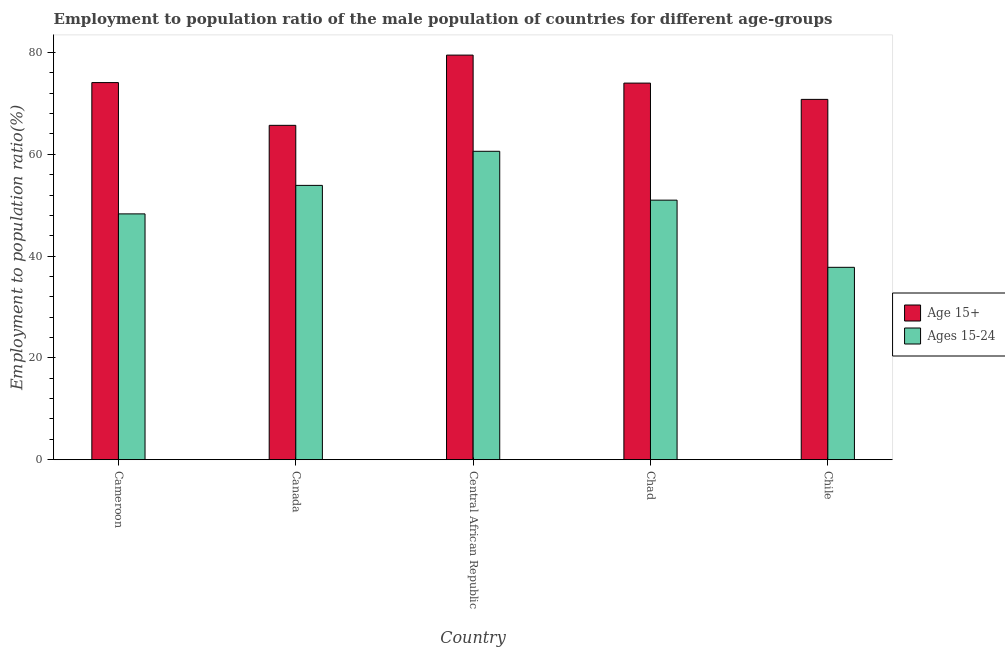How many groups of bars are there?
Ensure brevity in your answer.  5. Are the number of bars on each tick of the X-axis equal?
Keep it short and to the point. Yes. How many bars are there on the 2nd tick from the left?
Provide a short and direct response. 2. What is the label of the 1st group of bars from the left?
Your response must be concise. Cameroon. In how many cases, is the number of bars for a given country not equal to the number of legend labels?
Provide a short and direct response. 0. What is the employment to population ratio(age 15-24) in Cameroon?
Give a very brief answer. 48.3. Across all countries, what is the maximum employment to population ratio(age 15+)?
Give a very brief answer. 79.5. Across all countries, what is the minimum employment to population ratio(age 15-24)?
Provide a succinct answer. 37.8. In which country was the employment to population ratio(age 15+) maximum?
Provide a succinct answer. Central African Republic. In which country was the employment to population ratio(age 15+) minimum?
Give a very brief answer. Canada. What is the total employment to population ratio(age 15+) in the graph?
Ensure brevity in your answer.  364.1. What is the difference between the employment to population ratio(age 15+) in Central African Republic and that in Chile?
Your response must be concise. 8.7. What is the difference between the employment to population ratio(age 15+) in Chad and the employment to population ratio(age 15-24) in Central African Republic?
Keep it short and to the point. 13.4. What is the average employment to population ratio(age 15+) per country?
Keep it short and to the point. 72.82. In how many countries, is the employment to population ratio(age 15+) greater than 72 %?
Ensure brevity in your answer.  3. What is the ratio of the employment to population ratio(age 15+) in Cameroon to that in Central African Republic?
Provide a succinct answer. 0.93. Is the employment to population ratio(age 15+) in Cameroon less than that in Chad?
Provide a succinct answer. No. What is the difference between the highest and the second highest employment to population ratio(age 15+)?
Offer a very short reply. 5.4. What is the difference between the highest and the lowest employment to population ratio(age 15-24)?
Offer a very short reply. 22.8. Is the sum of the employment to population ratio(age 15-24) in Cameroon and Chile greater than the maximum employment to population ratio(age 15+) across all countries?
Your answer should be compact. Yes. What does the 2nd bar from the left in Chad represents?
Your response must be concise. Ages 15-24. What does the 2nd bar from the right in Cameroon represents?
Your answer should be very brief. Age 15+. Are all the bars in the graph horizontal?
Your answer should be very brief. No. How many countries are there in the graph?
Provide a succinct answer. 5. What is the difference between two consecutive major ticks on the Y-axis?
Keep it short and to the point. 20. How are the legend labels stacked?
Your response must be concise. Vertical. What is the title of the graph?
Ensure brevity in your answer.  Employment to population ratio of the male population of countries for different age-groups. Does "Diarrhea" appear as one of the legend labels in the graph?
Provide a short and direct response. No. What is the label or title of the Y-axis?
Provide a short and direct response. Employment to population ratio(%). What is the Employment to population ratio(%) in Age 15+ in Cameroon?
Offer a terse response. 74.1. What is the Employment to population ratio(%) of Ages 15-24 in Cameroon?
Your answer should be very brief. 48.3. What is the Employment to population ratio(%) of Age 15+ in Canada?
Your answer should be very brief. 65.7. What is the Employment to population ratio(%) in Ages 15-24 in Canada?
Give a very brief answer. 53.9. What is the Employment to population ratio(%) in Age 15+ in Central African Republic?
Give a very brief answer. 79.5. What is the Employment to population ratio(%) of Ages 15-24 in Central African Republic?
Offer a very short reply. 60.6. What is the Employment to population ratio(%) of Age 15+ in Chile?
Your answer should be compact. 70.8. What is the Employment to population ratio(%) in Ages 15-24 in Chile?
Your answer should be compact. 37.8. Across all countries, what is the maximum Employment to population ratio(%) of Age 15+?
Offer a terse response. 79.5. Across all countries, what is the maximum Employment to population ratio(%) in Ages 15-24?
Offer a terse response. 60.6. Across all countries, what is the minimum Employment to population ratio(%) of Age 15+?
Make the answer very short. 65.7. Across all countries, what is the minimum Employment to population ratio(%) in Ages 15-24?
Keep it short and to the point. 37.8. What is the total Employment to population ratio(%) in Age 15+ in the graph?
Keep it short and to the point. 364.1. What is the total Employment to population ratio(%) of Ages 15-24 in the graph?
Ensure brevity in your answer.  251.6. What is the difference between the Employment to population ratio(%) in Age 15+ in Cameroon and that in Canada?
Offer a terse response. 8.4. What is the difference between the Employment to population ratio(%) of Ages 15-24 in Cameroon and that in Central African Republic?
Offer a terse response. -12.3. What is the difference between the Employment to population ratio(%) of Age 15+ in Cameroon and that in Chad?
Offer a terse response. 0.1. What is the difference between the Employment to population ratio(%) in Ages 15-24 in Cameroon and that in Chile?
Your response must be concise. 10.5. What is the difference between the Employment to population ratio(%) in Age 15+ in Canada and that in Central African Republic?
Keep it short and to the point. -13.8. What is the difference between the Employment to population ratio(%) of Ages 15-24 in Canada and that in Central African Republic?
Your response must be concise. -6.7. What is the difference between the Employment to population ratio(%) in Age 15+ in Canada and that in Chad?
Give a very brief answer. -8.3. What is the difference between the Employment to population ratio(%) in Ages 15-24 in Canada and that in Chad?
Give a very brief answer. 2.9. What is the difference between the Employment to population ratio(%) of Age 15+ in Canada and that in Chile?
Your answer should be very brief. -5.1. What is the difference between the Employment to population ratio(%) of Ages 15-24 in Canada and that in Chile?
Your response must be concise. 16.1. What is the difference between the Employment to population ratio(%) in Age 15+ in Central African Republic and that in Chad?
Keep it short and to the point. 5.5. What is the difference between the Employment to population ratio(%) in Age 15+ in Central African Republic and that in Chile?
Provide a short and direct response. 8.7. What is the difference between the Employment to population ratio(%) in Ages 15-24 in Central African Republic and that in Chile?
Offer a terse response. 22.8. What is the difference between the Employment to population ratio(%) of Age 15+ in Chad and that in Chile?
Your answer should be very brief. 3.2. What is the difference between the Employment to population ratio(%) of Ages 15-24 in Chad and that in Chile?
Offer a terse response. 13.2. What is the difference between the Employment to population ratio(%) of Age 15+ in Cameroon and the Employment to population ratio(%) of Ages 15-24 in Canada?
Your answer should be compact. 20.2. What is the difference between the Employment to population ratio(%) of Age 15+ in Cameroon and the Employment to population ratio(%) of Ages 15-24 in Chad?
Your answer should be very brief. 23.1. What is the difference between the Employment to population ratio(%) in Age 15+ in Cameroon and the Employment to population ratio(%) in Ages 15-24 in Chile?
Keep it short and to the point. 36.3. What is the difference between the Employment to population ratio(%) of Age 15+ in Canada and the Employment to population ratio(%) of Ages 15-24 in Central African Republic?
Keep it short and to the point. 5.1. What is the difference between the Employment to population ratio(%) of Age 15+ in Canada and the Employment to population ratio(%) of Ages 15-24 in Chile?
Offer a terse response. 27.9. What is the difference between the Employment to population ratio(%) in Age 15+ in Central African Republic and the Employment to population ratio(%) in Ages 15-24 in Chad?
Your answer should be very brief. 28.5. What is the difference between the Employment to population ratio(%) of Age 15+ in Central African Republic and the Employment to population ratio(%) of Ages 15-24 in Chile?
Provide a short and direct response. 41.7. What is the difference between the Employment to population ratio(%) of Age 15+ in Chad and the Employment to population ratio(%) of Ages 15-24 in Chile?
Offer a terse response. 36.2. What is the average Employment to population ratio(%) of Age 15+ per country?
Give a very brief answer. 72.82. What is the average Employment to population ratio(%) of Ages 15-24 per country?
Provide a short and direct response. 50.32. What is the difference between the Employment to population ratio(%) of Age 15+ and Employment to population ratio(%) of Ages 15-24 in Cameroon?
Provide a short and direct response. 25.8. What is the ratio of the Employment to population ratio(%) of Age 15+ in Cameroon to that in Canada?
Offer a very short reply. 1.13. What is the ratio of the Employment to population ratio(%) of Ages 15-24 in Cameroon to that in Canada?
Keep it short and to the point. 0.9. What is the ratio of the Employment to population ratio(%) of Age 15+ in Cameroon to that in Central African Republic?
Give a very brief answer. 0.93. What is the ratio of the Employment to population ratio(%) in Ages 15-24 in Cameroon to that in Central African Republic?
Your answer should be compact. 0.8. What is the ratio of the Employment to population ratio(%) of Ages 15-24 in Cameroon to that in Chad?
Make the answer very short. 0.95. What is the ratio of the Employment to population ratio(%) in Age 15+ in Cameroon to that in Chile?
Ensure brevity in your answer.  1.05. What is the ratio of the Employment to population ratio(%) in Ages 15-24 in Cameroon to that in Chile?
Give a very brief answer. 1.28. What is the ratio of the Employment to population ratio(%) in Age 15+ in Canada to that in Central African Republic?
Provide a short and direct response. 0.83. What is the ratio of the Employment to population ratio(%) in Ages 15-24 in Canada to that in Central African Republic?
Your answer should be compact. 0.89. What is the ratio of the Employment to population ratio(%) in Age 15+ in Canada to that in Chad?
Keep it short and to the point. 0.89. What is the ratio of the Employment to population ratio(%) in Ages 15-24 in Canada to that in Chad?
Provide a short and direct response. 1.06. What is the ratio of the Employment to population ratio(%) of Age 15+ in Canada to that in Chile?
Give a very brief answer. 0.93. What is the ratio of the Employment to population ratio(%) of Ages 15-24 in Canada to that in Chile?
Your answer should be very brief. 1.43. What is the ratio of the Employment to population ratio(%) in Age 15+ in Central African Republic to that in Chad?
Your answer should be compact. 1.07. What is the ratio of the Employment to population ratio(%) in Ages 15-24 in Central African Republic to that in Chad?
Make the answer very short. 1.19. What is the ratio of the Employment to population ratio(%) in Age 15+ in Central African Republic to that in Chile?
Ensure brevity in your answer.  1.12. What is the ratio of the Employment to population ratio(%) in Ages 15-24 in Central African Republic to that in Chile?
Offer a very short reply. 1.6. What is the ratio of the Employment to population ratio(%) of Age 15+ in Chad to that in Chile?
Give a very brief answer. 1.05. What is the ratio of the Employment to population ratio(%) in Ages 15-24 in Chad to that in Chile?
Offer a terse response. 1.35. What is the difference between the highest and the second highest Employment to population ratio(%) of Ages 15-24?
Offer a very short reply. 6.7. What is the difference between the highest and the lowest Employment to population ratio(%) of Ages 15-24?
Provide a succinct answer. 22.8. 